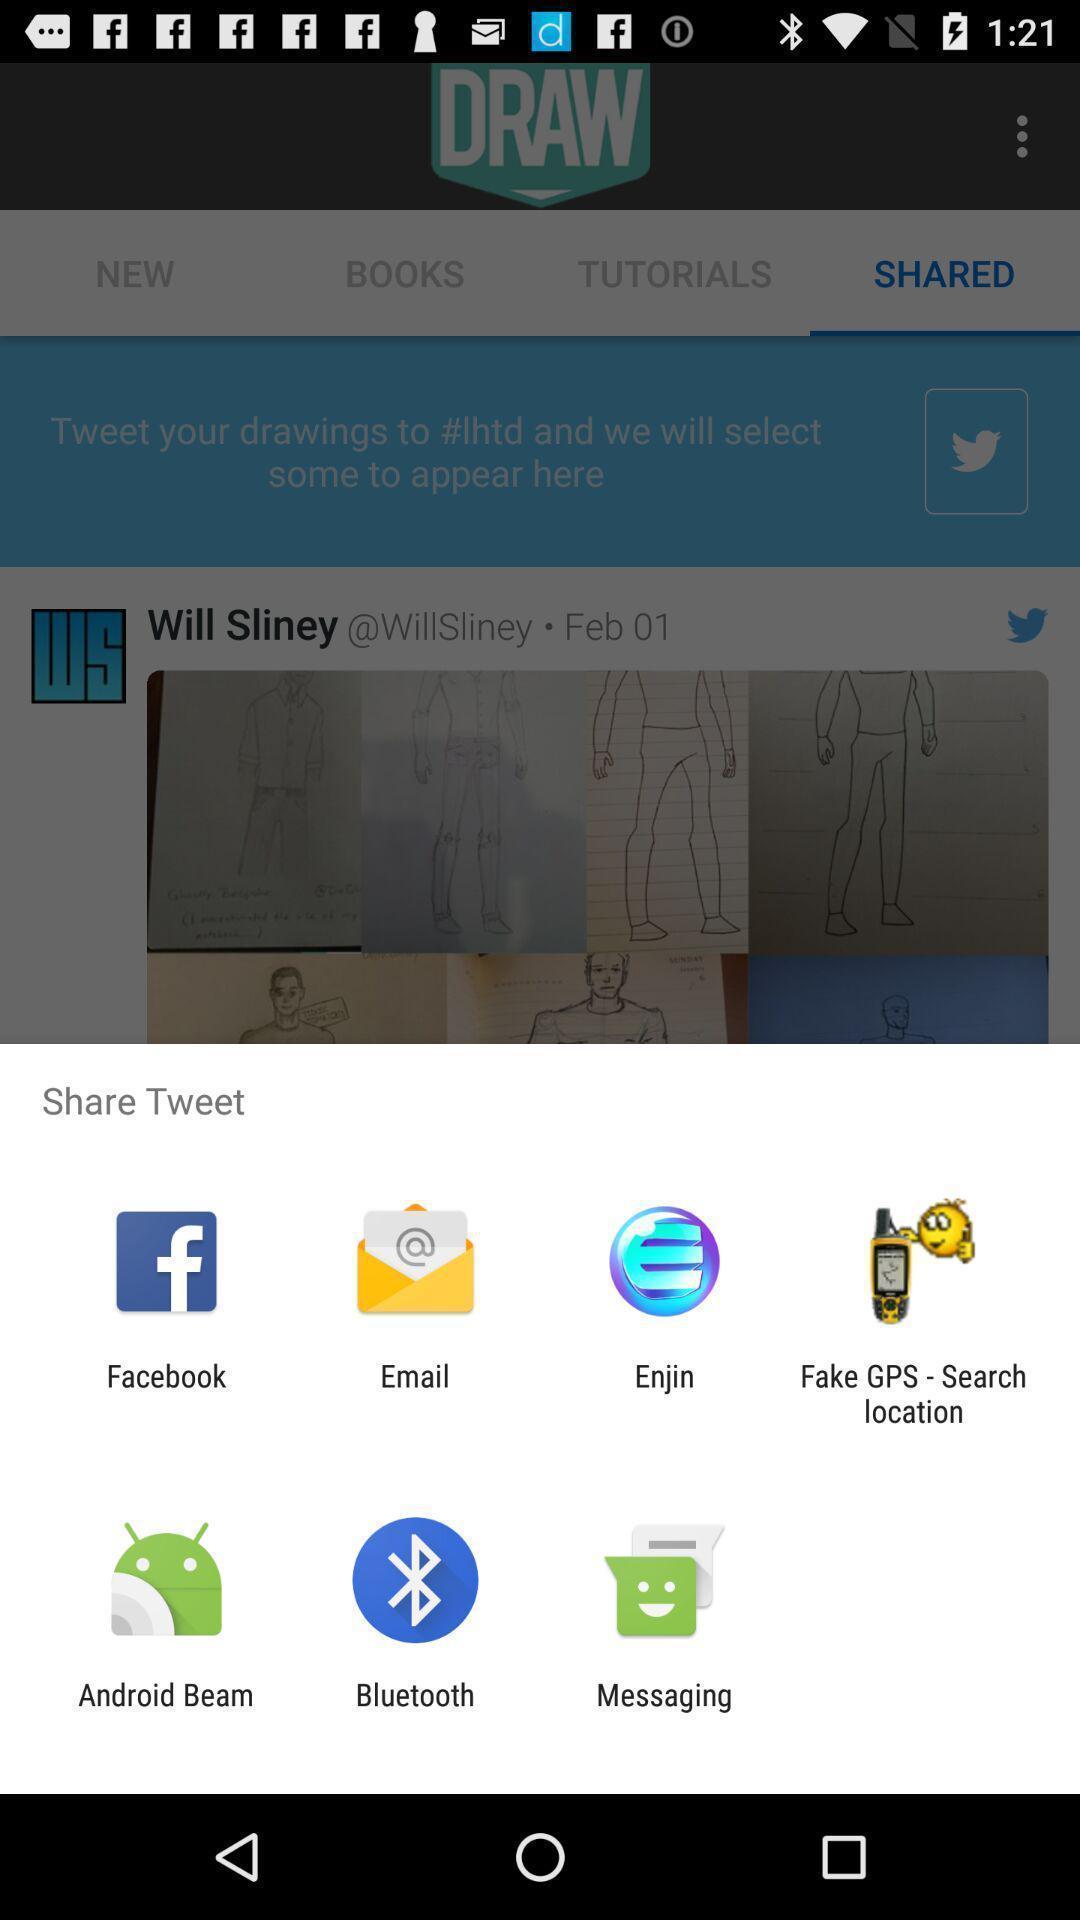Explain what's happening in this screen capture. Pop-up widget showing multiple data transferring apps. 